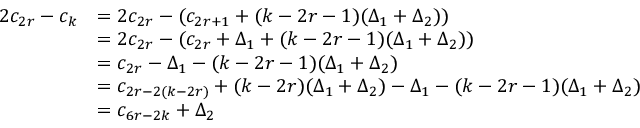Convert formula to latex. <formula><loc_0><loc_0><loc_500><loc_500>\begin{array} { r l } { 2 c _ { 2 r } - c _ { k } } & { = 2 c _ { 2 r } - ( c _ { 2 r + 1 } + ( k - 2 r - 1 ) ( \Delta _ { 1 } + \Delta _ { 2 } ) ) } \\ & { = 2 c _ { 2 r } - ( c _ { 2 r } + \Delta _ { 1 } + ( k - 2 r - 1 ) ( \Delta _ { 1 } + \Delta _ { 2 } ) ) } \\ & { = c _ { 2 r } - \Delta _ { 1 } - ( k - 2 r - 1 ) ( \Delta _ { 1 } + \Delta _ { 2 } ) } \\ & { = c _ { 2 r - 2 ( k - 2 r ) } + ( k - 2 r ) ( \Delta _ { 1 } + \Delta _ { 2 } ) - \Delta _ { 1 } - ( k - 2 r - 1 ) ( \Delta _ { 1 } + \Delta _ { 2 } ) } \\ & { = c _ { 6 r - 2 k } + \Delta _ { 2 } } \end{array}</formula> 